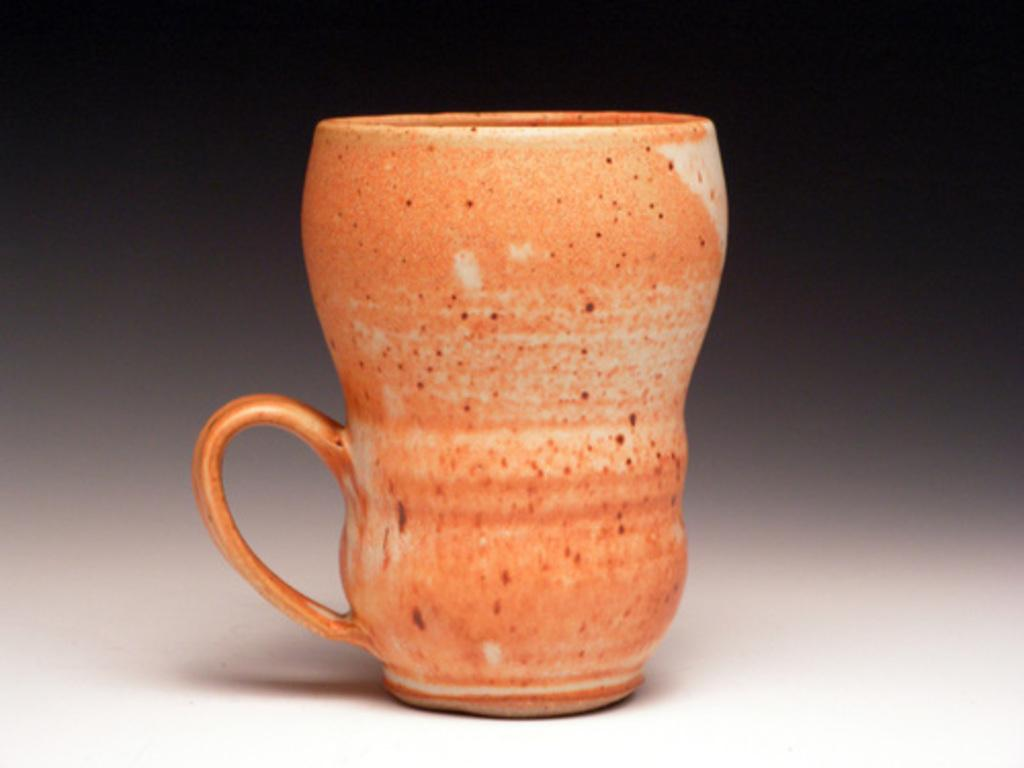What object is the main focus of the image? There is a mug in the image. Can you describe the background of the image? The background of the image is blurry. What type of fish is swimming in the mug in the image? There is no fish present in the image; it only features a mug. 